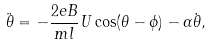Convert formula to latex. <formula><loc_0><loc_0><loc_500><loc_500>\ddot { \theta } = - \frac { 2 e B } { m l } U \cos ( \theta - \phi ) - \alpha \dot { \theta } ,</formula> 